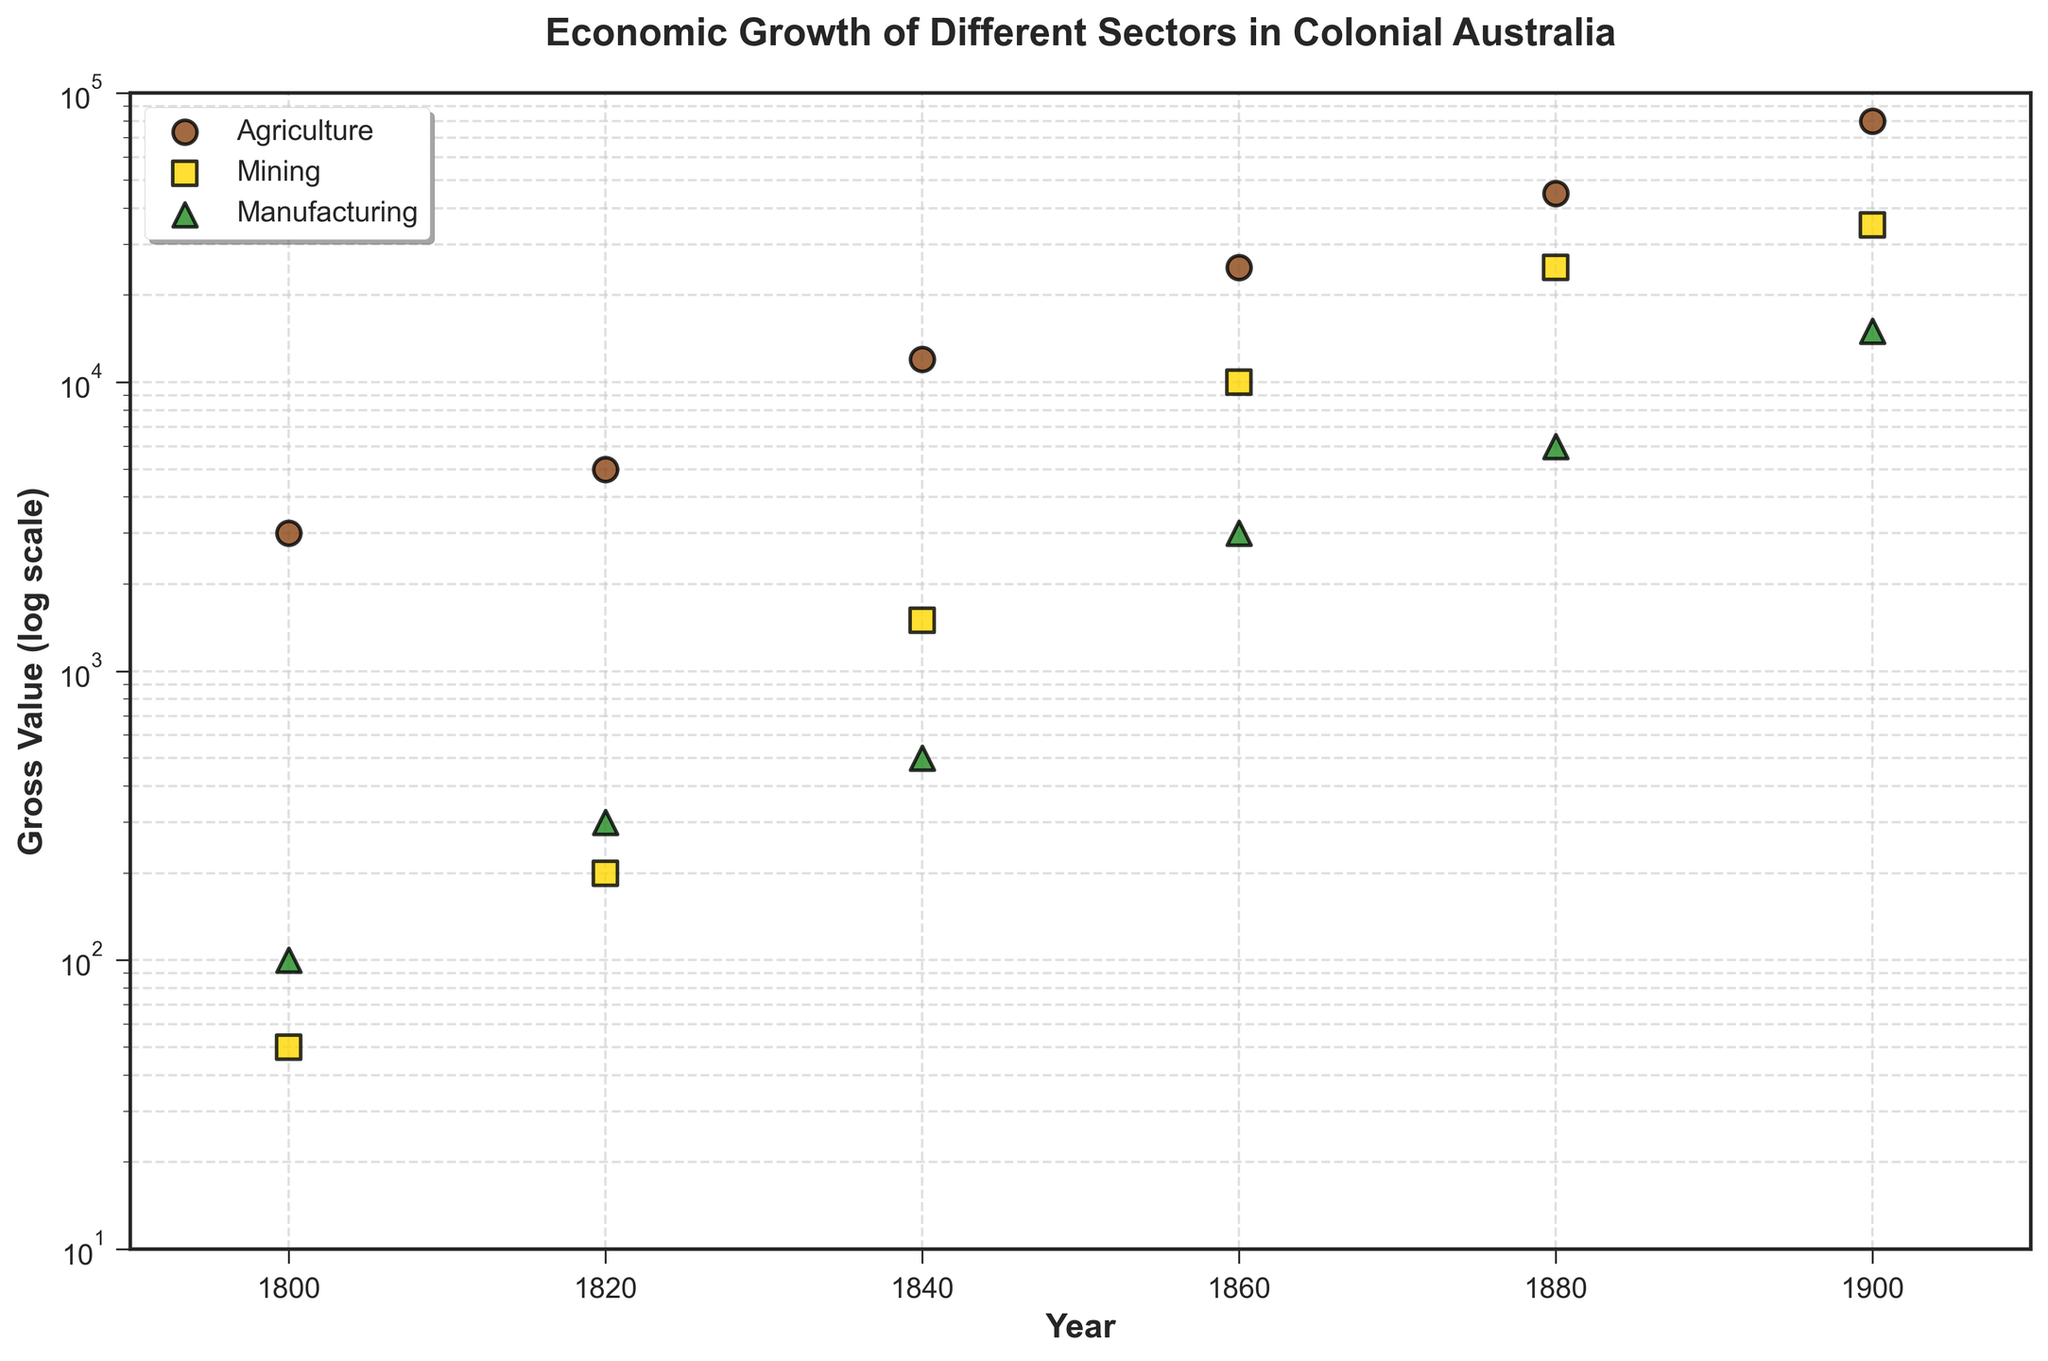What is the title of the figure? The title can be found at the top of the figure; it is the largest and boldest text, clearly stated to give an overview of the plot's main subject.
Answer: Economic Growth of Different Sectors in Colonial Australia What is the range of years shown on the scatter plot? The x-axis represents the years, with the range extending from the lowest year to the highest year visible in the figure.
Answer: 1790 to 1910 Which sector had the highest gross value in 1900? Locate the year 1900 on the x-axis and compare the gross values of the different sectors at that point. The highest gross value will be the uppermost point along the y-axis for that year.
Answer: Agriculture Between which years did the mining sector see its greatest increase in gross value? Look at the points representing mining gross value and find the two years where the vertical distance between the points is greatest, indicating the largest increase.
Answer: 1820 to 1840 Compare the growth of agriculture and manufacturing from 1800 to 1900. Which sector shows a larger relative increase? Calculate the ratio of gross values for each sector between 1900 and 1800, then compare these ratios to determine the sector with the larger relative increase.
Answer: Agriculture What is the gross value of manufacturing in 1860? Find the point on the scatter plot that corresponds to the year 1860 for the manufacturing sector and read its y-axis value.
Answer: 3000 How does the gross value of mining in 1880 compare to agriculture in 1840? Find the corresponding points and values for mining in 1880 and agriculture in 1840. Then, compare these two y-axis values directly.
Answer: Mining in 1880 is greater than agriculture in 1840 Between 1820 and 1880, which sector shows consistent growth with no decreases? Evaluate each sector individually by following their points from 1820 to 1880 and ensuring that each subsequent point is higher than the previous one.
Answer: Agriculture What are the different marker shapes used to represent various sectors? Identify the distinct shapes of markers on the scatter plot, each representing a different sector, as indicated by the plot legend.
Answer: Circles, squares, and triangles By what factor did the gross value of agriculture increase from 1800 to 1840? Divide the gross value of agriculture in 1840 by its gross value in 1800 to find the multiplicative factor of growth.
Answer: 4 